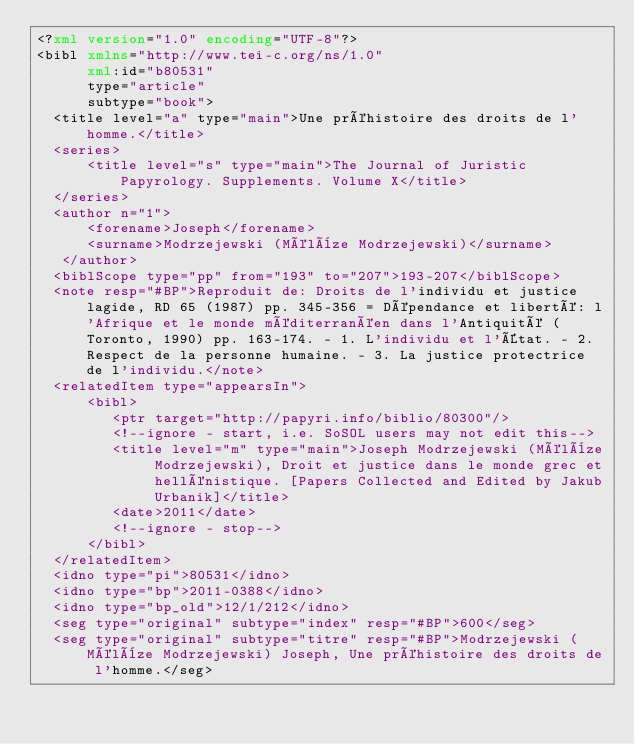<code> <loc_0><loc_0><loc_500><loc_500><_XML_><?xml version="1.0" encoding="UTF-8"?>
<bibl xmlns="http://www.tei-c.org/ns/1.0"
      xml:id="b80531"
      type="article"
      subtype="book">
  <title level="a" type="main">Une préhistoire des droits de l'homme.</title>
  <series>
      <title level="s" type="main">The Journal of Juristic Papyrology. Supplements. Volume X</title>
  </series>
  <author n="1">
      <forename>Joseph</forename>
      <surname>Modrzejewski (Mélèze Modrzejewski)</surname>
   </author>
  <biblScope type="pp" from="193" to="207">193-207</biblScope>
  <note resp="#BP">Reproduit de: Droits de l'individu et justice lagide, RD 65 (1987) pp. 345-356 = Dépendance et liberté: l'Afrique et le monde méditerranéen dans l'Antiquité (Toronto, 1990) pp. 163-174. - 1. L'individu et l'État. - 2. Respect de la personne humaine. - 3. La justice protectrice de l'individu.</note>
  <relatedItem type="appearsIn">
      <bibl>
         <ptr target="http://papyri.info/biblio/80300"/>
         <!--ignore - start, i.e. SoSOL users may not edit this-->
         <title level="m" type="main">Joseph Modrzejewski (Mélèze Modrzejewski), Droit et justice dans le monde grec et hellénistique. [Papers Collected and Edited by Jakub Urbanik]</title>
         <date>2011</date>
         <!--ignore - stop-->
      </bibl>
  </relatedItem>
  <idno type="pi">80531</idno>
  <idno type="bp">2011-0388</idno>
  <idno type="bp_old">12/1/212</idno>
  <seg type="original" subtype="index" resp="#BP">600</seg>
  <seg type="original" subtype="titre" resp="#BP">Modrzejewski (Mélèze Modrzejewski) Joseph, Une préhistoire des droits de l'homme.</seg></code> 